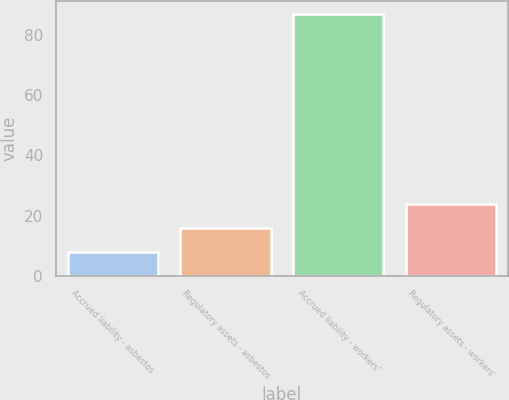Convert chart to OTSL. <chart><loc_0><loc_0><loc_500><loc_500><bar_chart><fcel>Accrued liability - asbestos<fcel>Regulatory assets - asbestos<fcel>Accrued liability - workers'<fcel>Regulatory assets - workers'<nl><fcel>8<fcel>15.9<fcel>87<fcel>23.8<nl></chart> 